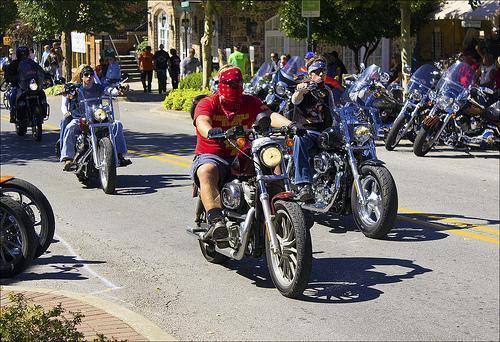How many headlights does the motorcycle have?
Give a very brief answer. 1. How many people are driving motorcycles?
Give a very brief answer. 4. How many women are riding motorcycles?
Give a very brief answer. 0. How many headlights are on?
Give a very brief answer. 4. How many tires can be seen?
Give a very brief answer. 10. 